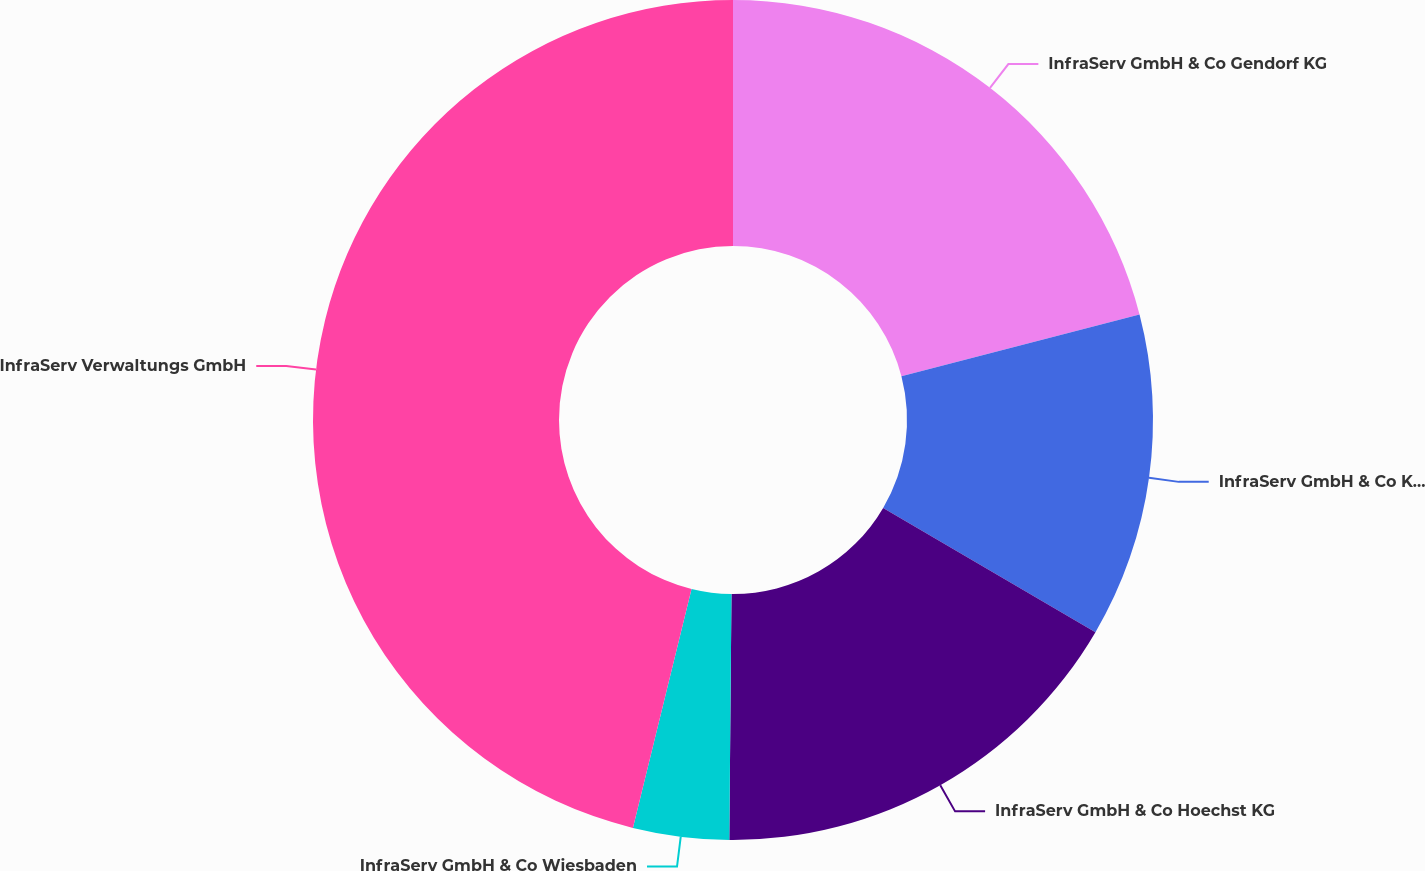Convert chart to OTSL. <chart><loc_0><loc_0><loc_500><loc_500><pie_chart><fcel>InfraServ GmbH & Co Gendorf KG<fcel>InfraServ GmbH & Co Knapsack<fcel>InfraServ GmbH & Co Hoechst KG<fcel>InfraServ GmbH & Co Wiesbaden<fcel>InfraServ Verwaltungs GmbH<nl><fcel>20.96%<fcel>12.47%<fcel>16.71%<fcel>3.69%<fcel>46.17%<nl></chart> 